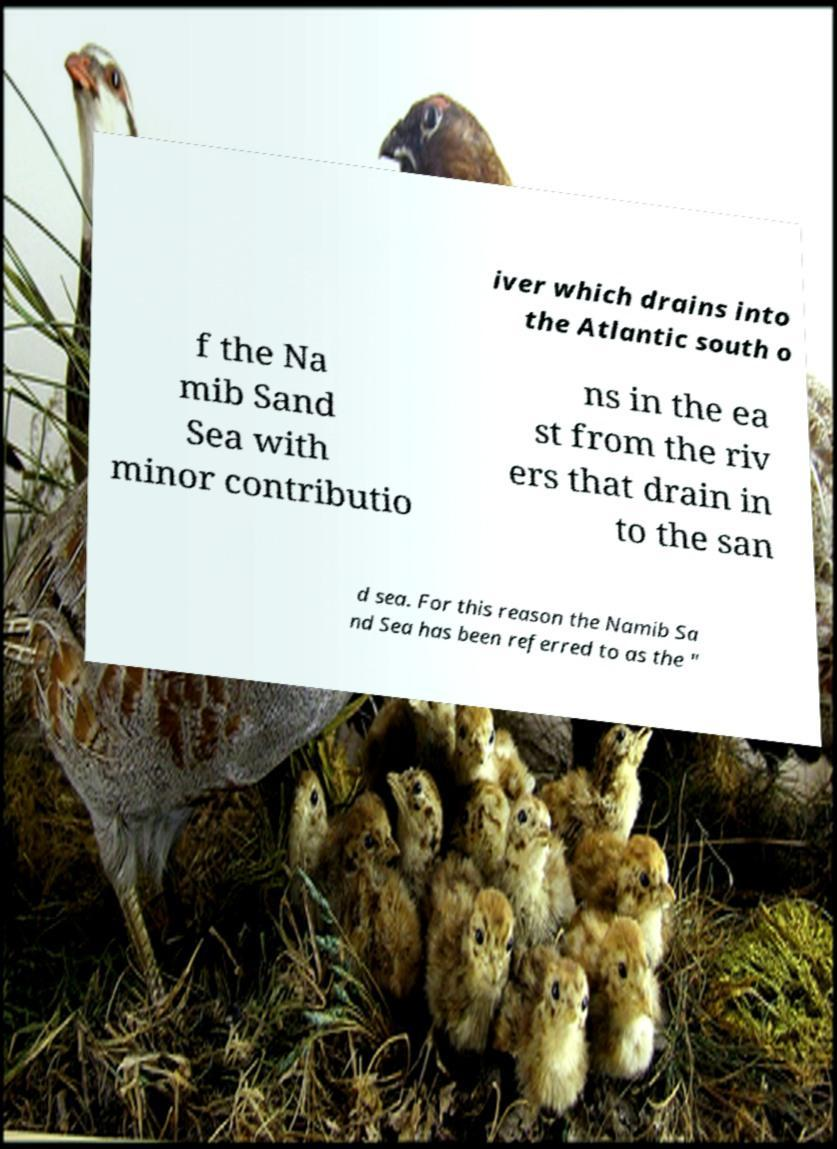Could you extract and type out the text from this image? iver which drains into the Atlantic south o f the Na mib Sand Sea with minor contributio ns in the ea st from the riv ers that drain in to the san d sea. For this reason the Namib Sa nd Sea has been referred to as the " 